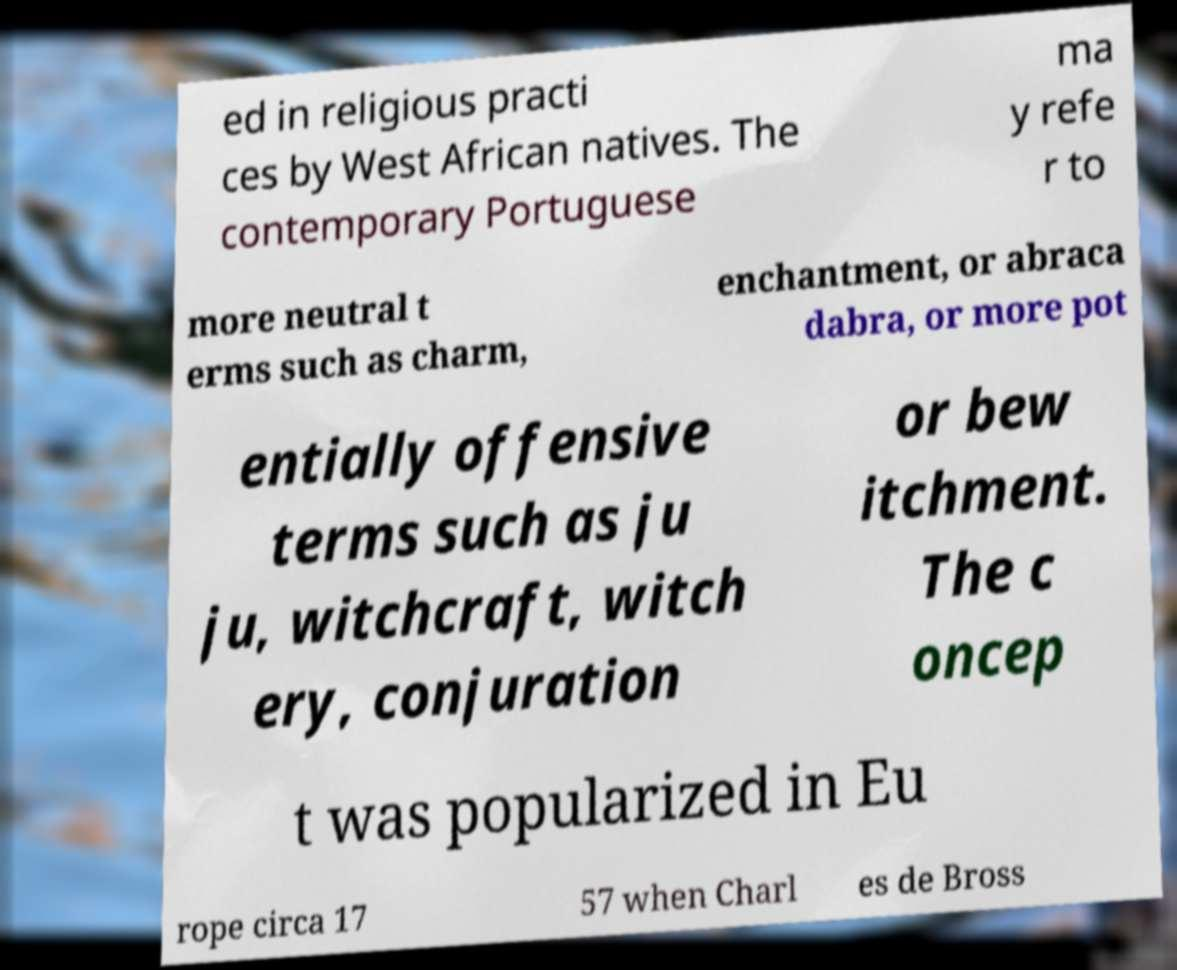Can you read and provide the text displayed in the image?This photo seems to have some interesting text. Can you extract and type it out for me? ed in religious practi ces by West African natives. The contemporary Portuguese ma y refe r to more neutral t erms such as charm, enchantment, or abraca dabra, or more pot entially offensive terms such as ju ju, witchcraft, witch ery, conjuration or bew itchment. The c oncep t was popularized in Eu rope circa 17 57 when Charl es de Bross 